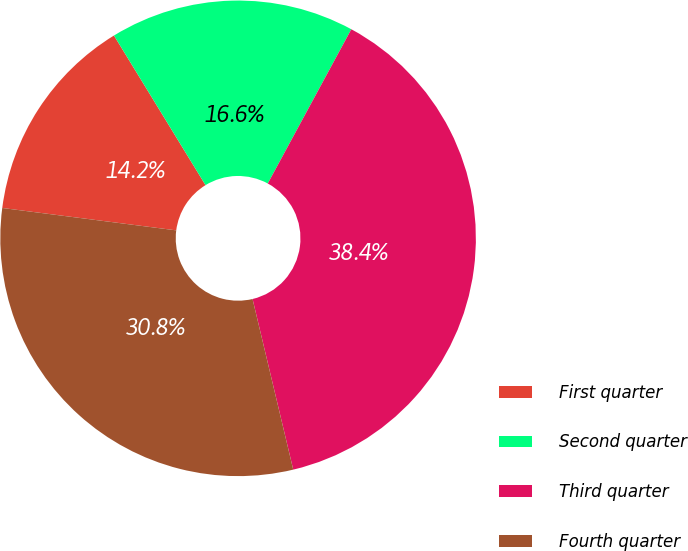Convert chart. <chart><loc_0><loc_0><loc_500><loc_500><pie_chart><fcel>First quarter<fcel>Second quarter<fcel>Third quarter<fcel>Fourth quarter<nl><fcel>14.22%<fcel>16.64%<fcel>38.37%<fcel>30.76%<nl></chart> 